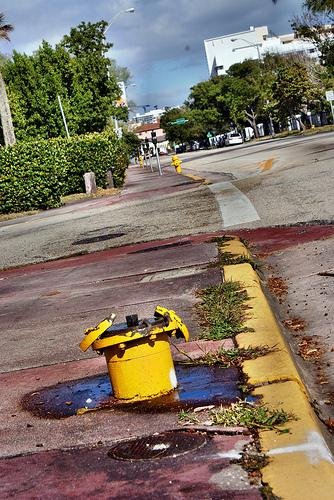Question: when was the photo taken?
Choices:
A. Day time.
B. Nighttime.
C. Morning.
D. Sunset.
Answer with the letter. Answer: A Question: why is it so bright?
Choices:
A. Moonlight.
B. Sunny.
C. Candles.
D. Camp fire.
Answer with the letter. Answer: B 